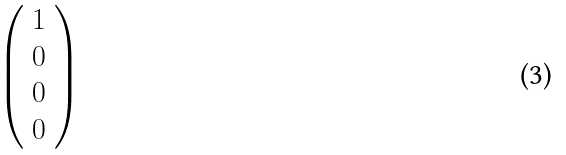<formula> <loc_0><loc_0><loc_500><loc_500>\left ( \begin{array} { l } { 1 } \\ { 0 } \\ { 0 } \\ { 0 } \end{array} \right )</formula> 